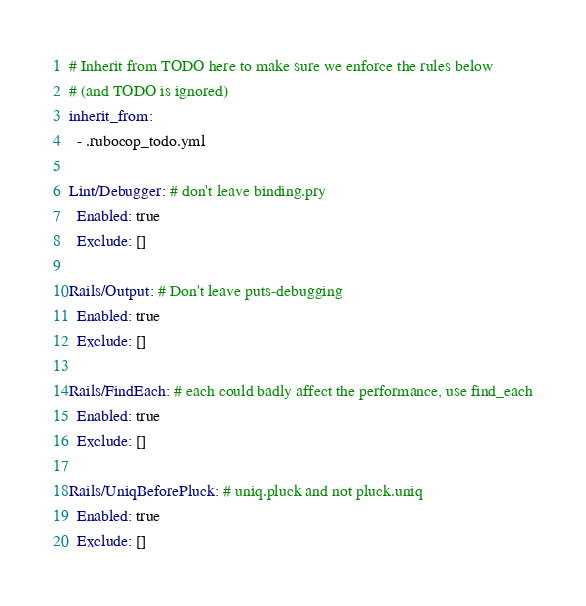Convert code to text. <code><loc_0><loc_0><loc_500><loc_500><_YAML_># Inherit from TODO here to make sure we enforce the rules below
# (and TODO is ignored)
inherit_from:
  - .rubocop_todo.yml

Lint/Debugger: # don't leave binding.pry
  Enabled: true
  Exclude: []

Rails/Output: # Don't leave puts-debugging
  Enabled: true
  Exclude: []

Rails/FindEach: # each could badly affect the performance, use find_each
  Enabled: true
  Exclude: []

Rails/UniqBeforePluck: # uniq.pluck and not pluck.uniq
  Enabled: true
  Exclude: []</code> 